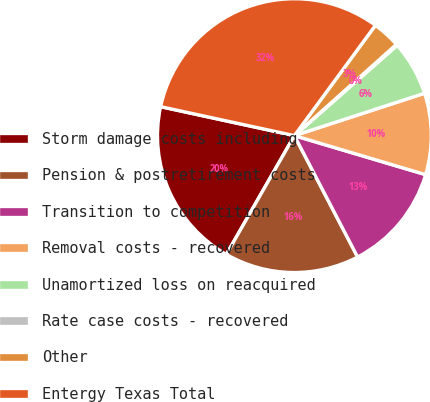Convert chart. <chart><loc_0><loc_0><loc_500><loc_500><pie_chart><fcel>Storm damage costs including<fcel>Pension & postretirement costs<fcel>Transition to competition<fcel>Removal costs - recovered<fcel>Unamortized loss on reacquired<fcel>Rate case costs - recovered<fcel>Other<fcel>Entergy Texas Total<nl><fcel>20.12%<fcel>15.92%<fcel>12.76%<fcel>9.61%<fcel>6.46%<fcel>0.15%<fcel>3.3%<fcel>31.69%<nl></chart> 